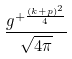<formula> <loc_0><loc_0><loc_500><loc_500>\frac { g ^ { + \frac { ( k + p ) ^ { 2 } } { 4 } } } { \sqrt { 4 \pi } }</formula> 